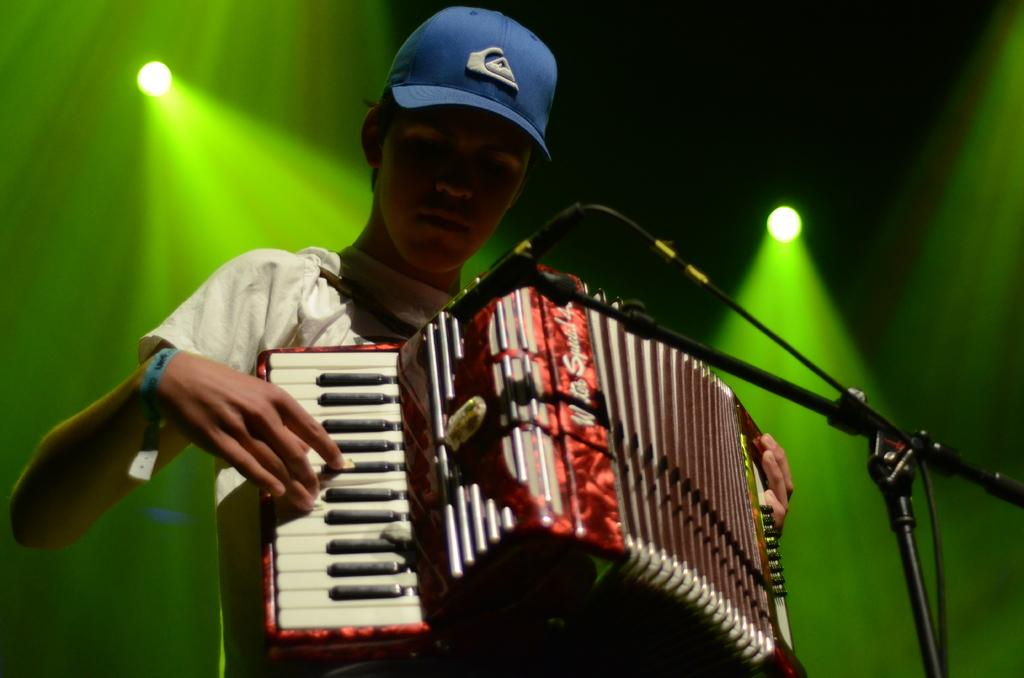Who is the main subject in the image? There is a man in the image. What is the man holding in the image? The man is holding a musical instrument. What is the man doing with the musical instrument? The man is playing the musical instrument. What type of sheet is the man using to play the musical instrument? There is no sheet present in the image, and the man is not using any sheet to play the musical instrument. 